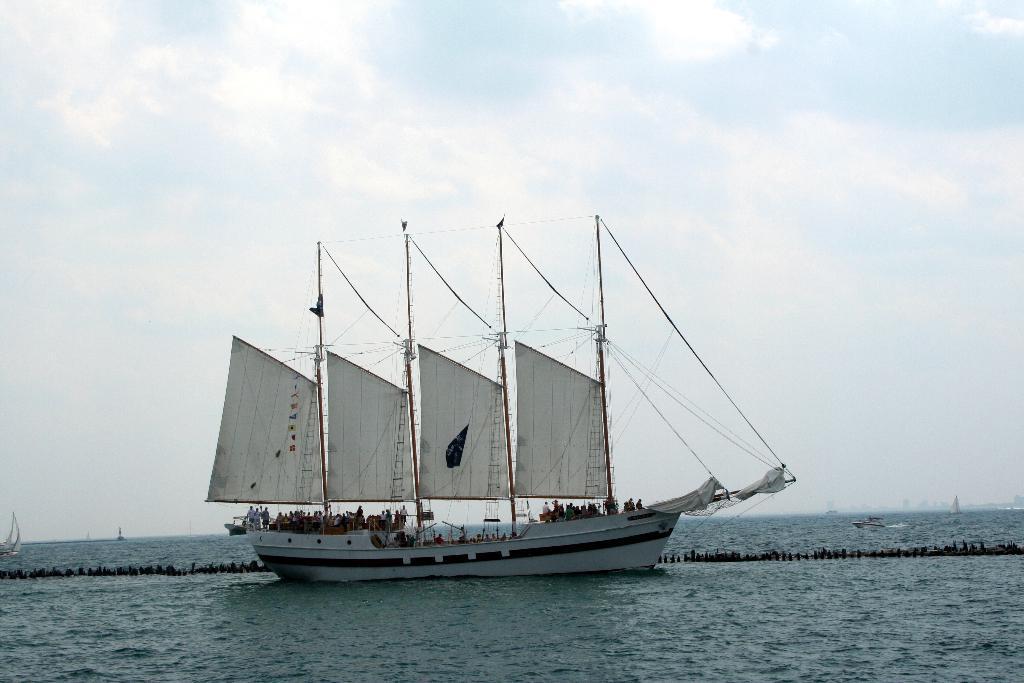Please provide a concise description of this image. In the picture we can see a boat on the water and behind it, we can see the sky with clouds. 